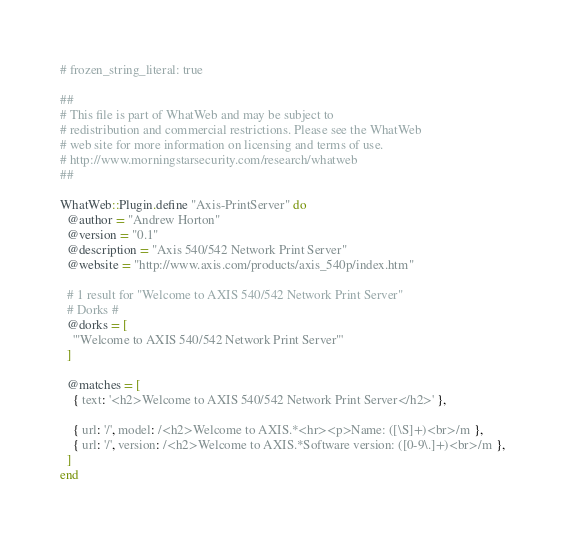<code> <loc_0><loc_0><loc_500><loc_500><_Ruby_># frozen_string_literal: true

##
# This file is part of WhatWeb and may be subject to
# redistribution and commercial restrictions. Please see the WhatWeb
# web site for more information on licensing and terms of use.
# http://www.morningstarsecurity.com/research/whatweb
##

WhatWeb::Plugin.define "Axis-PrintServer" do
  @author = "Andrew Horton"
  @version = "0.1"
  @description = "Axis 540/542 Network Print Server"
  @website = "http://www.axis.com/products/axis_540p/index.htm"

  # 1 result for "Welcome to AXIS 540/542 Network Print Server"
  # Dorks #
  @dorks = [
    '"Welcome to AXIS 540/542 Network Print Server"'
  ]

  @matches = [
    { text: '<h2>Welcome to AXIS 540/542 Network Print Server</h2>' },

    { url: '/', model: /<h2>Welcome to AXIS.*<hr><p>Name: ([\S]+)<br>/m },
    { url: '/', version: /<h2>Welcome to AXIS.*Software version: ([0-9\.]+)<br>/m },
  ]
end
</code> 